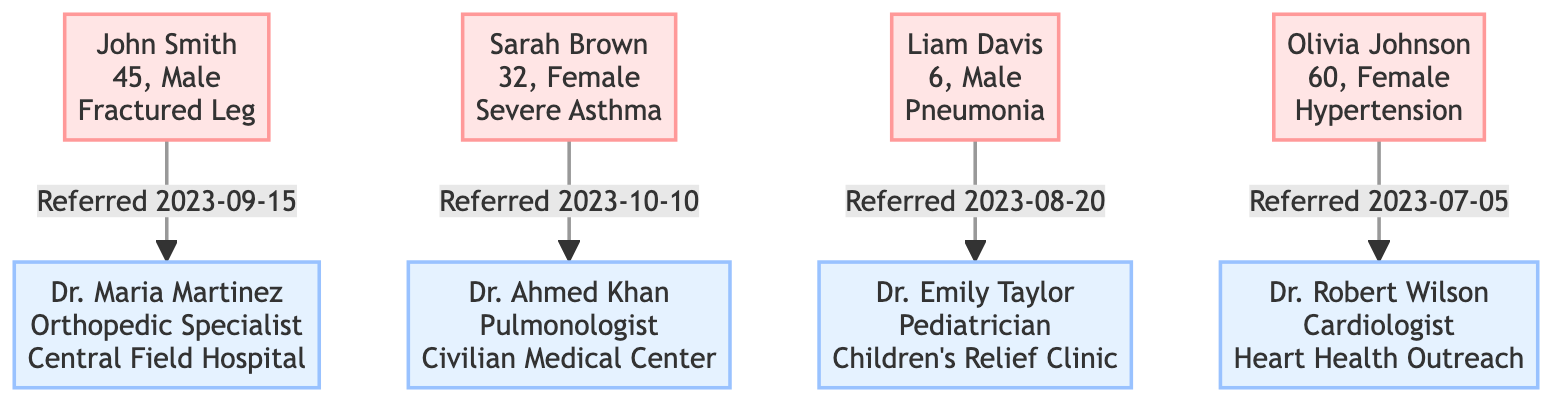What is the age of John Smith? The diagram shows John Smith's node which states "45" as his age.
Answer: 45 Who is the specialist for Sarah Brown? By looking at the link connected to Sarah Brown's node, it points to Dr. Ahmed Khan, who is designated as the Pulmonologist.
Answer: Dr. Ahmed Khan On what date was Olivia Johnson referred? The referral date is provided directly in the node for Olivia Johnson, which states "2023-07-05."
Answer: 2023-07-05 How many patients are referred to specialists in the diagram? Counting the patient nodes in the diagram, there are four patients listed: John Smith, Sarah Brown, Liam Davis, and Olivia Johnson.
Answer: 4 Who is the Pediatrician in the clinic? The designation of Pediatrician is linked to Dr. Emily Taylor, whose details are included in the diagram.
Answer: Dr. Emily Taylor What condition does Liam Davis have? Liam Davis's node specifies that he has Pneumonia, which answers the query directly.
Answer: Pneumonia Which location is associated with Dr. Maria Martinez? Dr. Maria Martinez's node mentions that her location is the "Central Field Hospital."
Answer: Central Field Hospital Which patient was referred most recently? Upon reviewing the referral dates in the nodes, Sarah Brown was referred on "2023-10-10," which is the latest date compared to others.
Answer: Sarah Brown What is Olivia Johnson's condition? The diagram indicates that Olivia Johnson has the condition of Hypertension, as stated in her node.
Answer: Hypertension 